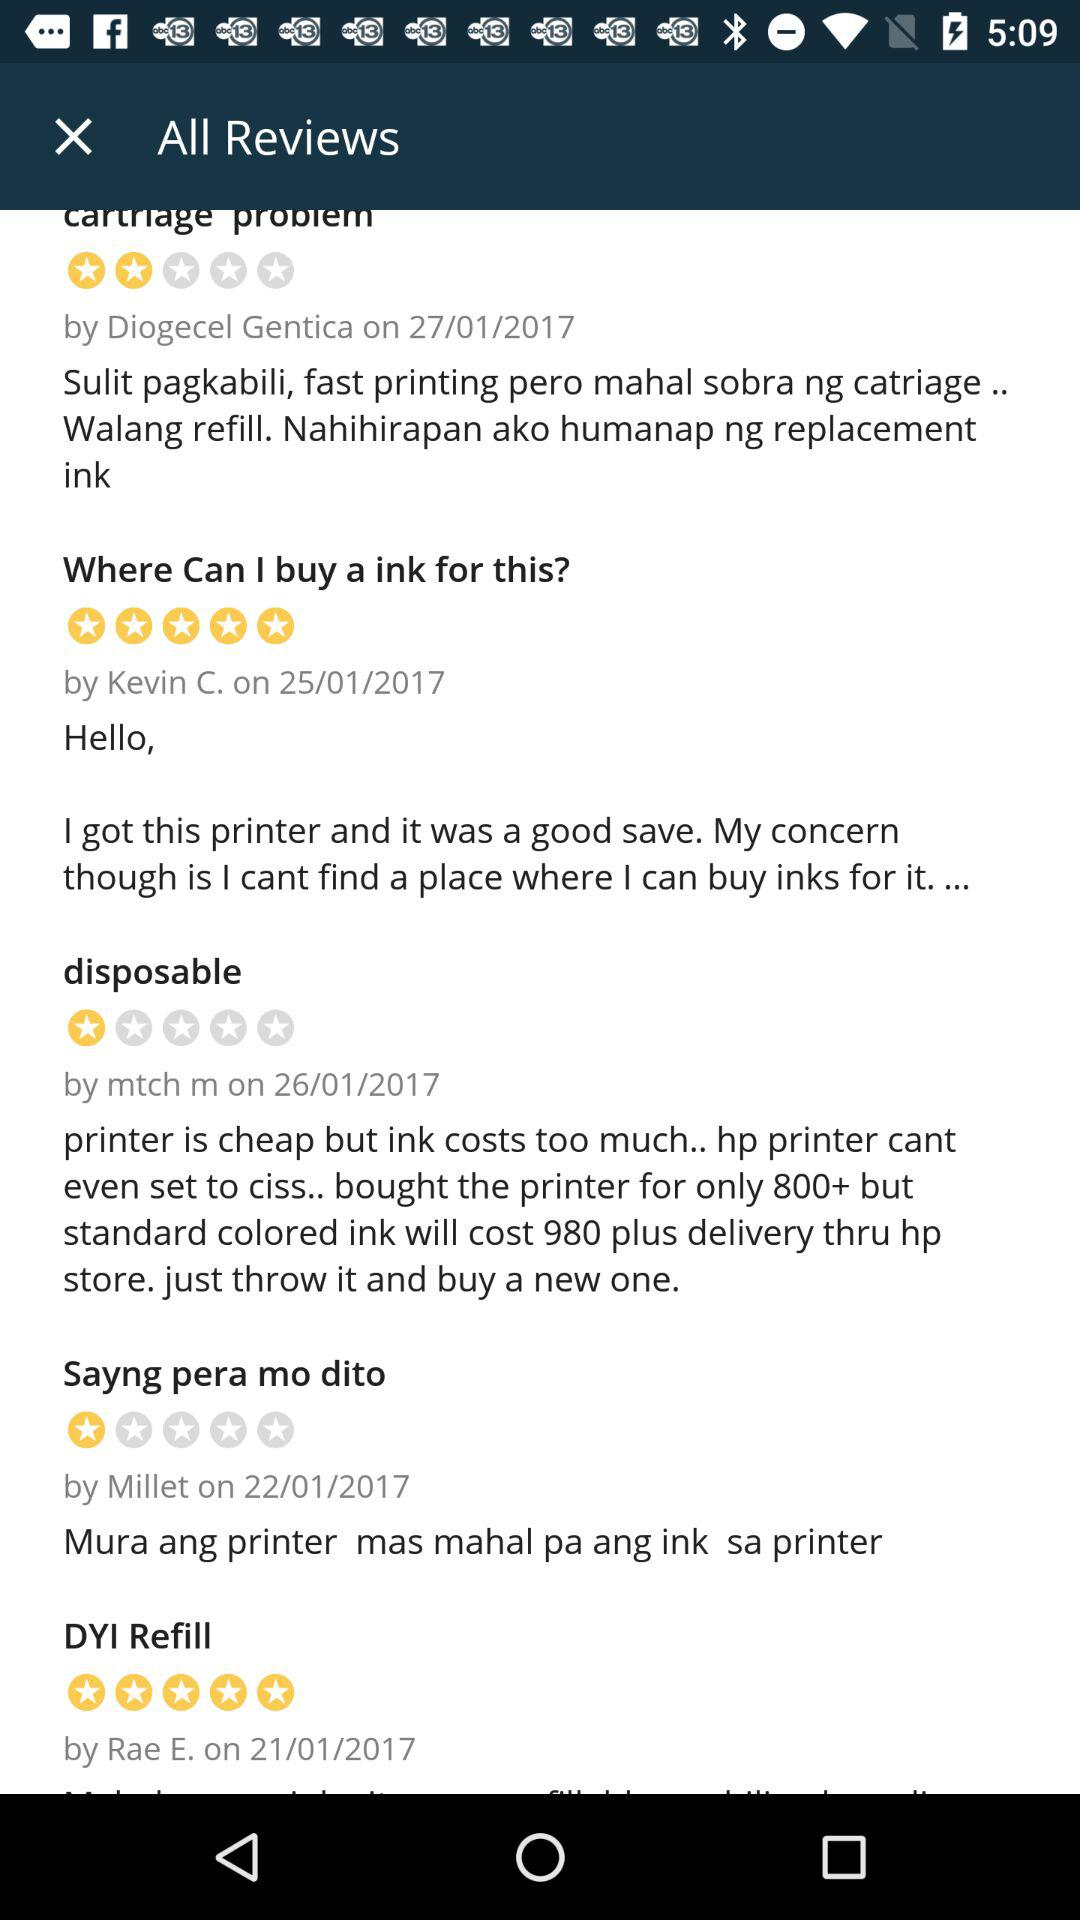What is the rating given by Millet? The rating given by Millet is 1 star. 